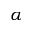<formula> <loc_0><loc_0><loc_500><loc_500>\alpha</formula> 